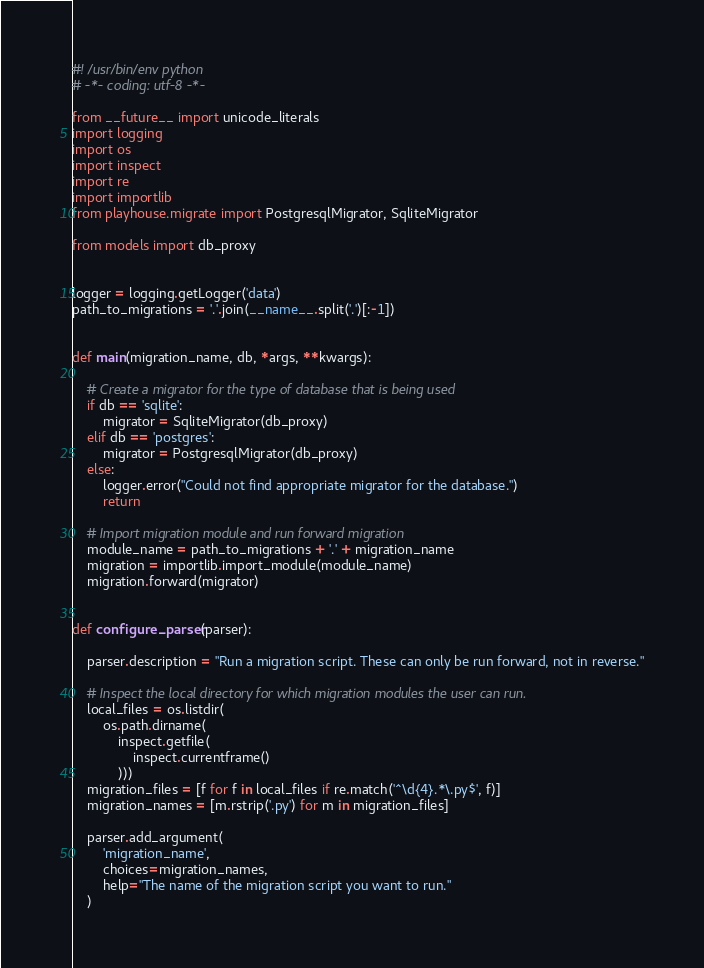Convert code to text. <code><loc_0><loc_0><loc_500><loc_500><_Python_>#! /usr/bin/env python
# -*- coding: utf-8 -*-

from __future__ import unicode_literals
import logging
import os
import inspect
import re
import importlib
from playhouse.migrate import PostgresqlMigrator, SqliteMigrator

from models import db_proxy


logger = logging.getLogger('data')
path_to_migrations = '.'.join(__name__.split('.')[:-1])


def main(migration_name, db, *args, **kwargs):

    # Create a migrator for the type of database that is being used
    if db == 'sqlite':
        migrator = SqliteMigrator(db_proxy)
    elif db == 'postgres':
        migrator = PostgresqlMigrator(db_proxy)
    else:
        logger.error("Could not find appropriate migrator for the database.")
        return

    # Import migration module and run forward migration
    module_name = path_to_migrations + '.' + migration_name
    migration = importlib.import_module(module_name)
    migration.forward(migrator)


def configure_parser(parser):

    parser.description = "Run a migration script. These can only be run forward, not in reverse."

    # Inspect the local directory for which migration modules the user can run.
    local_files = os.listdir(
        os.path.dirname(
            inspect.getfile(
                inspect.currentframe()
            )))
    migration_files = [f for f in local_files if re.match('^\d{4}.*\.py$', f)]
    migration_names = [m.rstrip('.py') for m in migration_files]

    parser.add_argument(
        'migration_name',
        choices=migration_names,
        help="The name of the migration script you want to run."
    )
</code> 